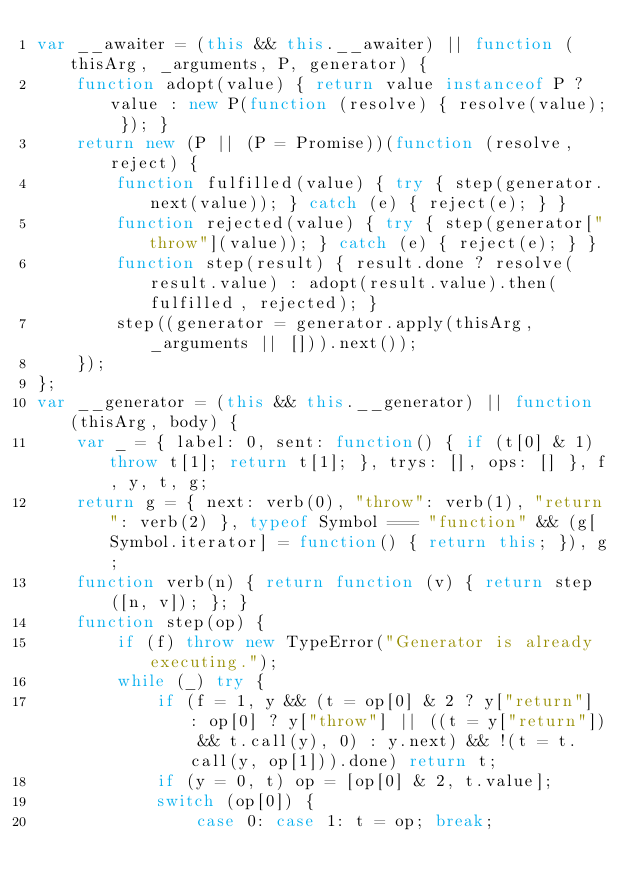Convert code to text. <code><loc_0><loc_0><loc_500><loc_500><_JavaScript_>var __awaiter = (this && this.__awaiter) || function (thisArg, _arguments, P, generator) {
    function adopt(value) { return value instanceof P ? value : new P(function (resolve) { resolve(value); }); }
    return new (P || (P = Promise))(function (resolve, reject) {
        function fulfilled(value) { try { step(generator.next(value)); } catch (e) { reject(e); } }
        function rejected(value) { try { step(generator["throw"](value)); } catch (e) { reject(e); } }
        function step(result) { result.done ? resolve(result.value) : adopt(result.value).then(fulfilled, rejected); }
        step((generator = generator.apply(thisArg, _arguments || [])).next());
    });
};
var __generator = (this && this.__generator) || function (thisArg, body) {
    var _ = { label: 0, sent: function() { if (t[0] & 1) throw t[1]; return t[1]; }, trys: [], ops: [] }, f, y, t, g;
    return g = { next: verb(0), "throw": verb(1), "return": verb(2) }, typeof Symbol === "function" && (g[Symbol.iterator] = function() { return this; }), g;
    function verb(n) { return function (v) { return step([n, v]); }; }
    function step(op) {
        if (f) throw new TypeError("Generator is already executing.");
        while (_) try {
            if (f = 1, y && (t = op[0] & 2 ? y["return"] : op[0] ? y["throw"] || ((t = y["return"]) && t.call(y), 0) : y.next) && !(t = t.call(y, op[1])).done) return t;
            if (y = 0, t) op = [op[0] & 2, t.value];
            switch (op[0]) {
                case 0: case 1: t = op; break;</code> 